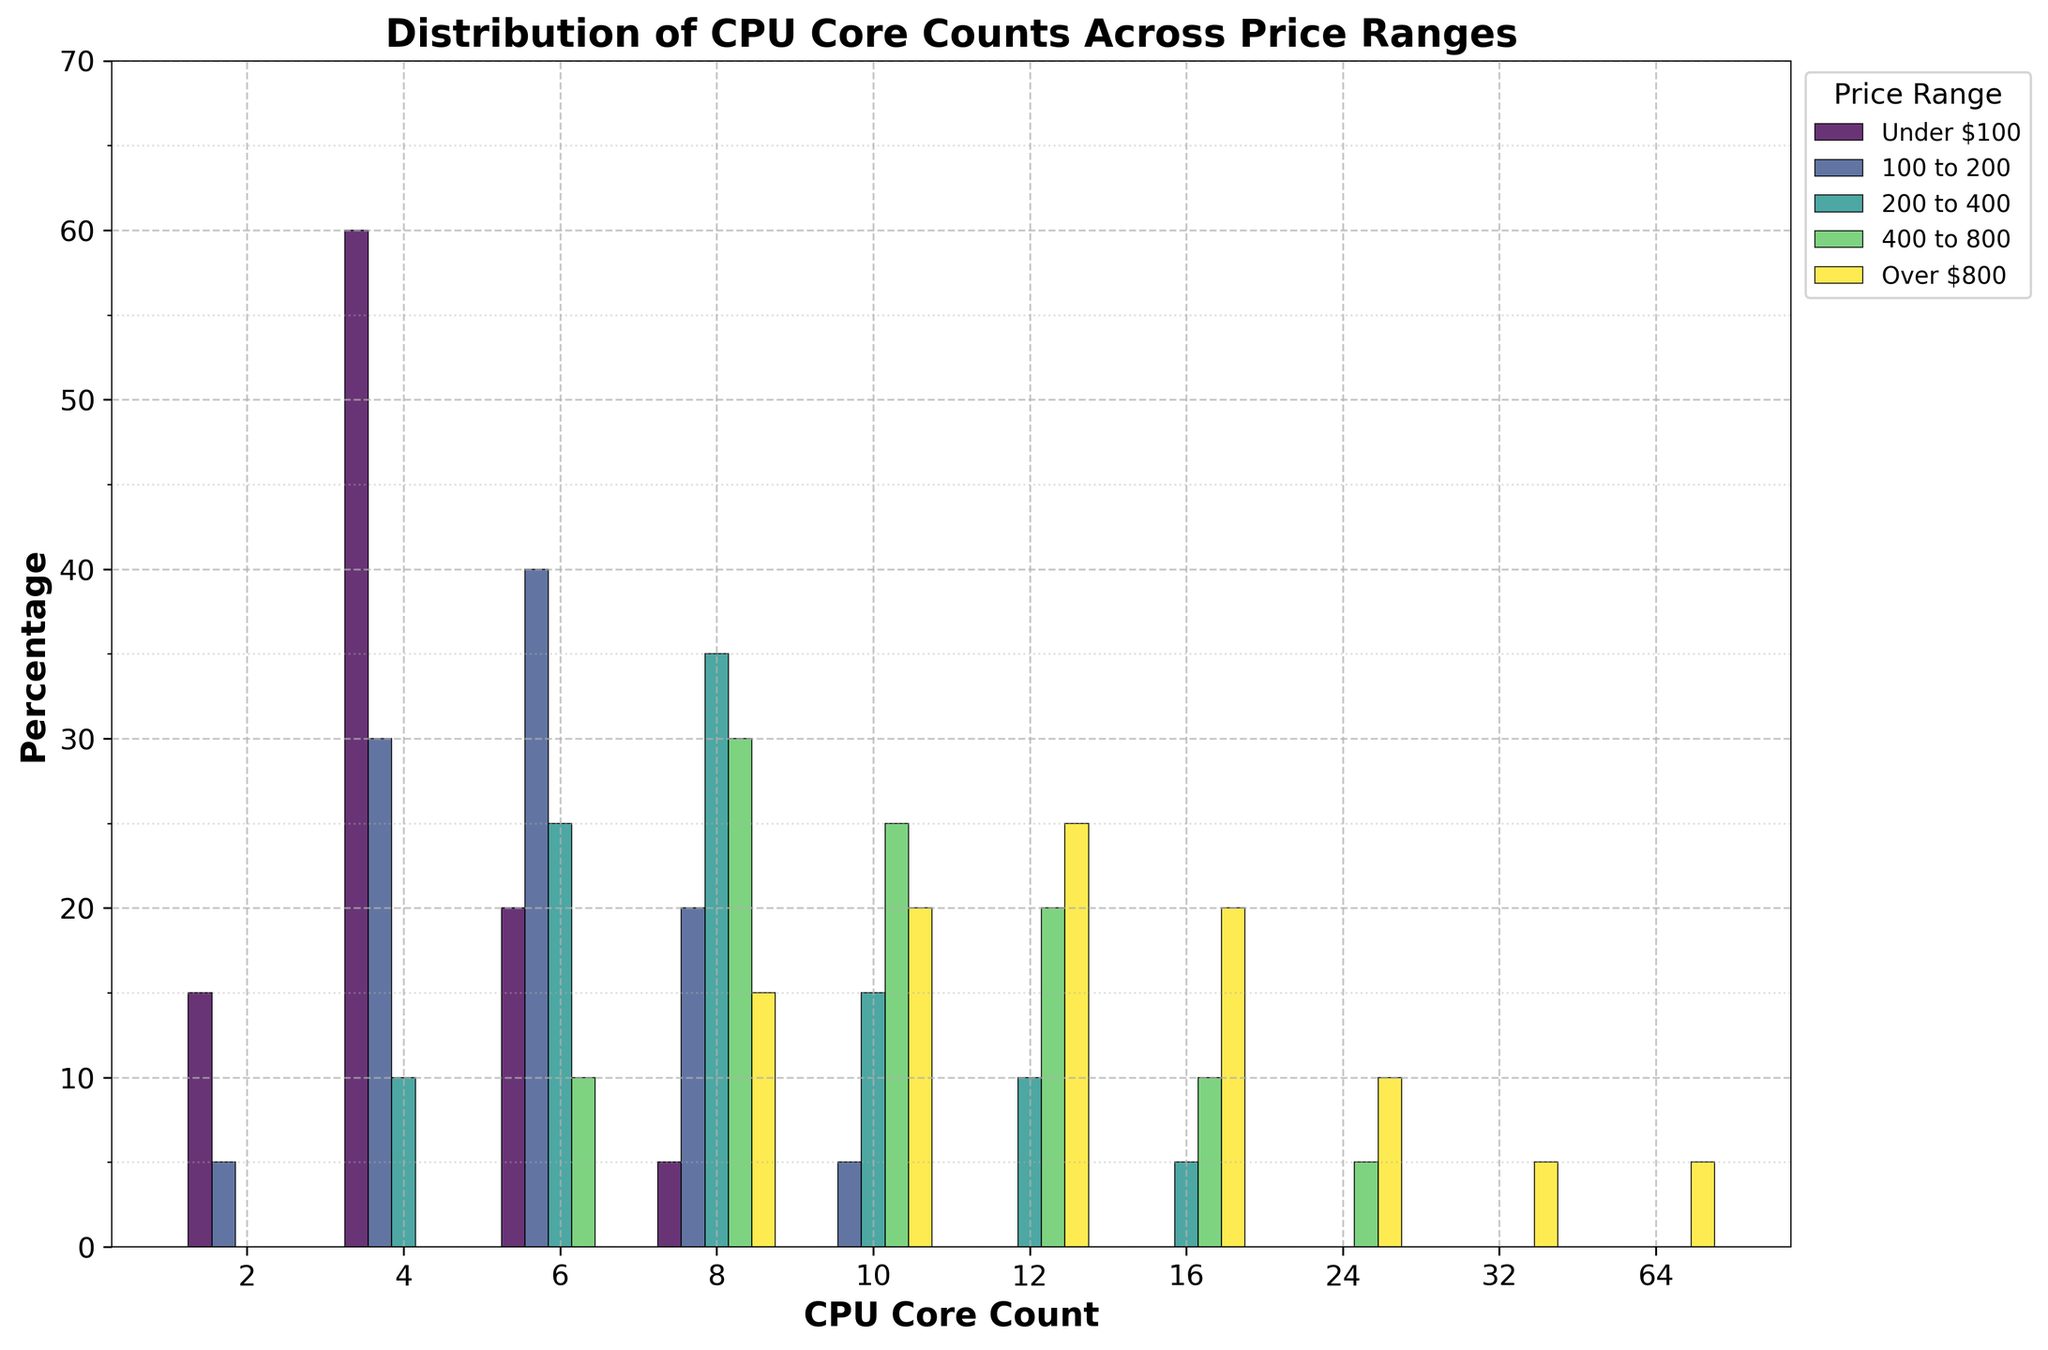What price range has the most processors with 4 cores? In the figure, the height of each bar represents the percentage of processors for each core count in a specific price range. For 4-core processors, the bar corresponding to the "Under $100" range is the tallest.
Answer: Under $100 Which core count category has the highest percentage of processors in the "200 to 400" price range? Looking at the bars in the "200 to 400" price range section, the tallest bar corresponds to the 8-core processors.
Answer: 8 cores What is the total percentage of processors with 6 or fewer cores in the "100 to 200" price range? Sum the heights of the bars for 2, 4, and 6-core processors in the "100 to 200" price range: 5% (2 cores) + 30% (4 cores) + 40% (6 cores) = 75%.
Answer: 75% Compare the percentage of processors with 10 cores in the "200 to 400" and "Over $800" price ranges. Which is greater? In the figure, the height of the bars for 10-core processors in the "200 to 400" and "Over $800" price ranges shows 15% and 20% respectively.
Answer: Over $800 How many core counts have at least one price range with more than 25% of processors? Based on the figure, bars over the 25% line exist for 4 cores in "Under $100" and "100 to 200", and 6 cores in "100 to 200". So, 2 core counts meet this criterion.
Answer: 2 core counts What is the minimum CPU core count found in the "Over $800" price range? The figure shows bars for 8-core, 10-core, 12-core, 16-core, 24-core, 32-core, and 64-core processors in the "Over $800" price range. The minimum core count here is 8.
Answer: 8 cores 